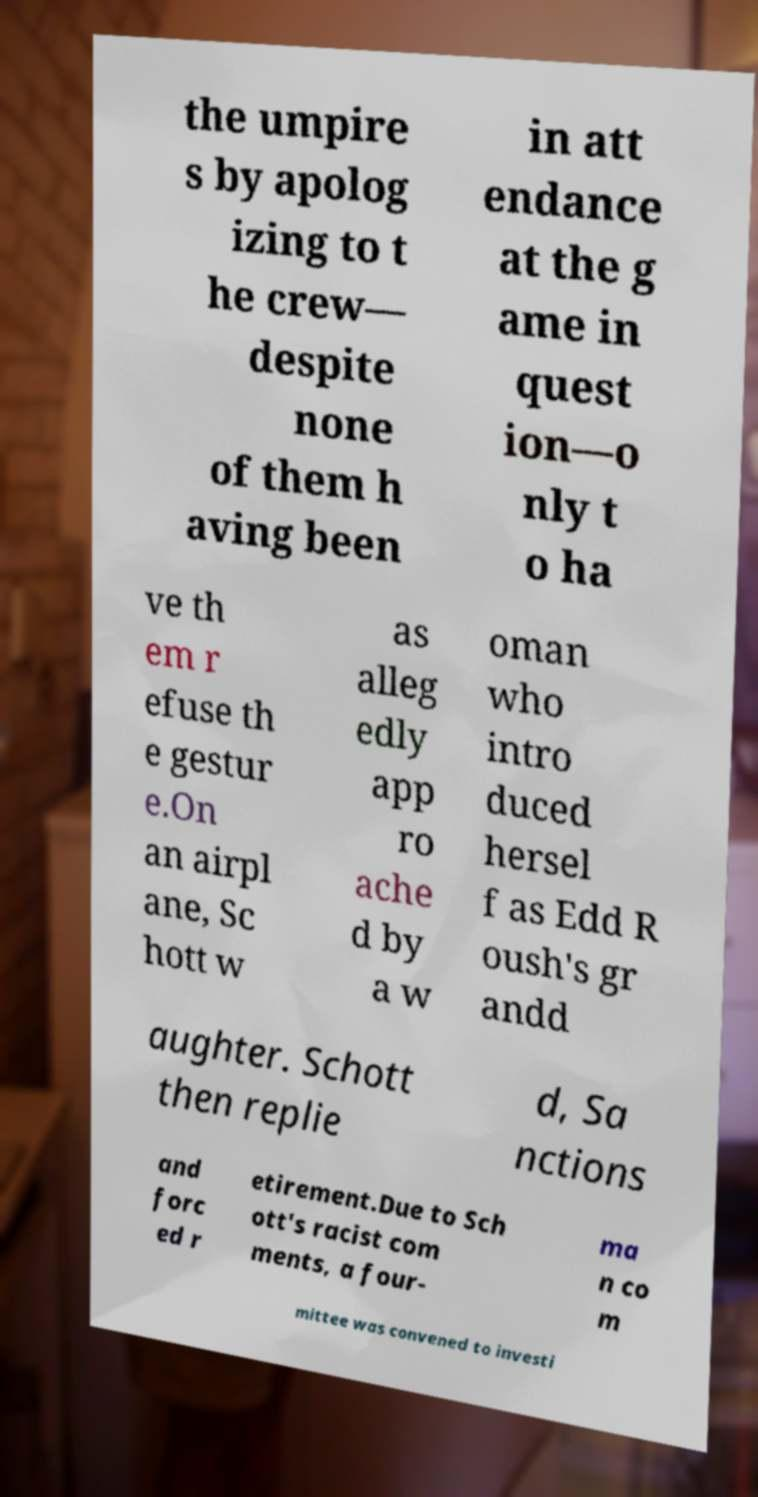I need the written content from this picture converted into text. Can you do that? the umpire s by apolog izing to t he crew— despite none of them h aving been in att endance at the g ame in quest ion—o nly t o ha ve th em r efuse th e gestur e.On an airpl ane, Sc hott w as alleg edly app ro ache d by a w oman who intro duced hersel f as Edd R oush's gr andd aughter. Schott then replie d, Sa nctions and forc ed r etirement.Due to Sch ott's racist com ments, a four- ma n co m mittee was convened to investi 